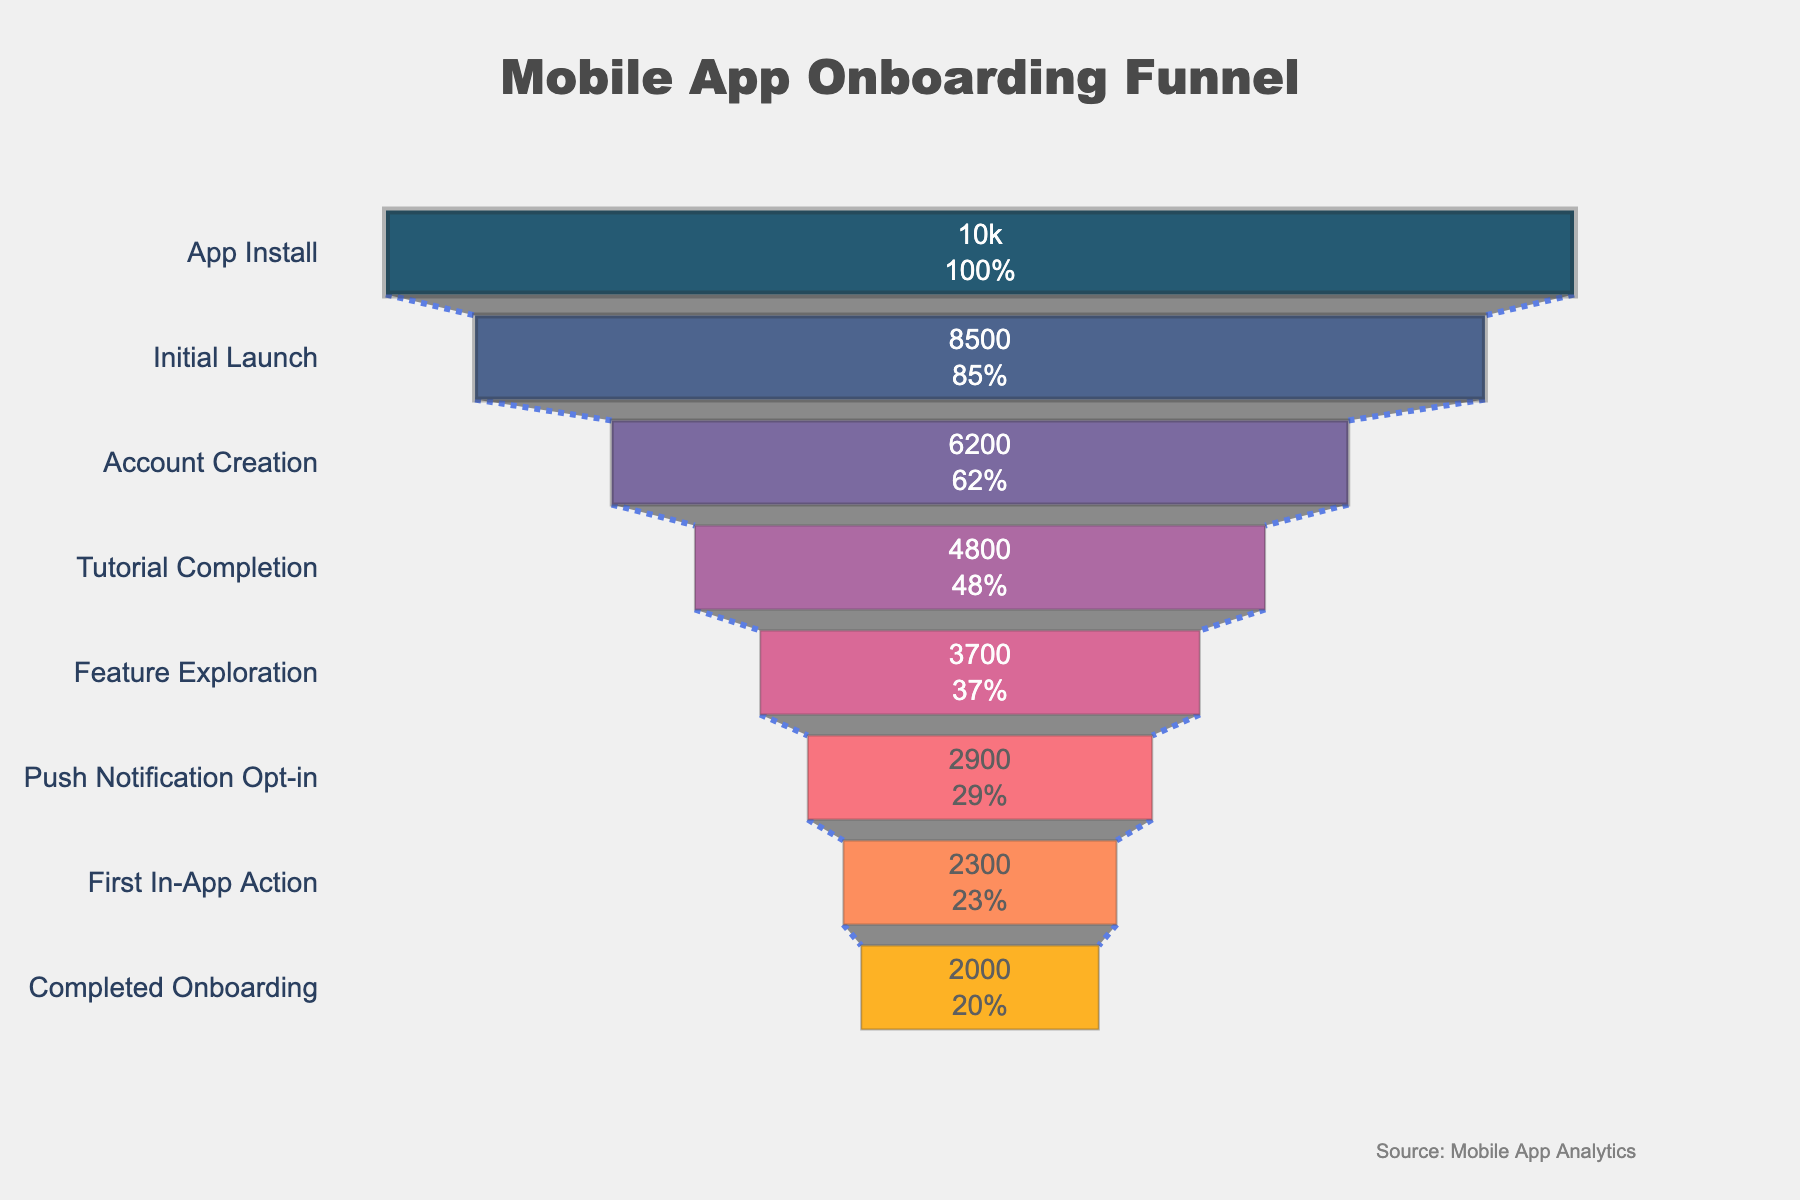What is the title of the funnel chart? The title is usually placed at the top of the chart. In this case, it's centrally aligned. It reads "Mobile App Onboarding Funnel" based on the visual information in the figure.
Answer: Mobile App Onboarding Funnel How many stages are there in the onboarding process? Each stage is represented by a segment in the funnel chart. Count the number of distinct segments or labels on the y-axis.
Answer: 8 What stage has the highest number of users? The stage with the highest number of users is the top segment of the funnel chart since more users will be at the start of the process.
Answer: App Install Which stage has the lowest number of users? The stage with the lowest number of users is at the bottom of the funnel, representing the end of the onboarding process where user drop-off is highest.
Answer: Completed Onboarding By what percentage do the users drop from the "App Install" stage to the "Initial Launch" stage? Looking at the funnel chart, locate the number of users at "App Install" and "Initial Launch" stages. Calculate the difference between these numbers, divide by the "App Install" users, and multiply by 100 to get the percentage. (10000 - 8500) / 10000 * 100 = 15%
Answer: 15% What's the user retention rate from "Account Creation" to "Tutorial Completion"? Locate the number of users in both stages from the funnel chart. Calculate the percentage of users who completed the "Tutorial Completion" stage out of those who started at "Account Creation" (4800 / 6200 * 100).
Answer: 77.42% Compare the number of users at "Feature Exploration" and "Push Notification Opt-in". Which stage has more users and by how much? Identify the number of users at both stages and subtract the smaller number from the larger one. (3700 - 2900). "Feature Exploration" has more users.
Answer: Feature Exploration by 800 Which stage shows the largest user dropout, and what is the difference in user numbers between that stage and the previous one? Look at each transitional drop and find the largest. The largest drop is between "Account Creation" and "Initial Launch" with (8500 - 6200) users.
Answer: Initial Launch to Account Creation, 2300 users What proportion of users who installed the app eventually completed the onboarding process? Calculate the percentage by dividing the number of users who completed onboarding by those who installed the app and multiply by 100. (2000 / 10000 * 100).
Answer: 20% If the conversion rate from "Tutorial Completion" to "Feature Exploration" could be increased by 10%, how many users would that add to the "Feature Exploration" stage (based on the same number of users at "Tutorial Completion")? Calculate the 10% increase of users transitioning from "Tutorial Completion" to "Feature Exploration". Currently, 4800 users completing the tutorial lead to 3700 users at exploration. An increase of 10% from 3700 is calculated as 3700 * 1.10 = 4070. Therefore, the additional users will be 4070 - 3700.
Answer: 370 users 